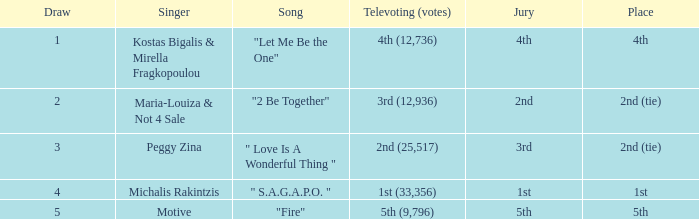In televoting (votes), which song secured the 2nd position (25,517)? " Love Is A Wonderful Thing ". 